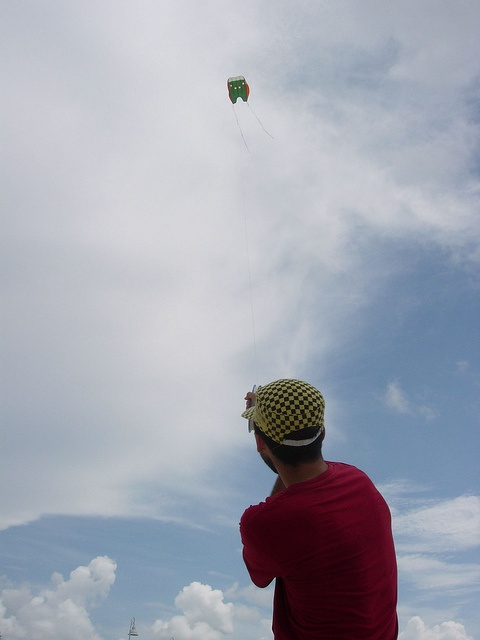Describe the objects in this image and their specific colors. I can see people in lightgray, black, maroon, olive, and gray tones and kite in lightgray, darkgreen, and darkgray tones in this image. 